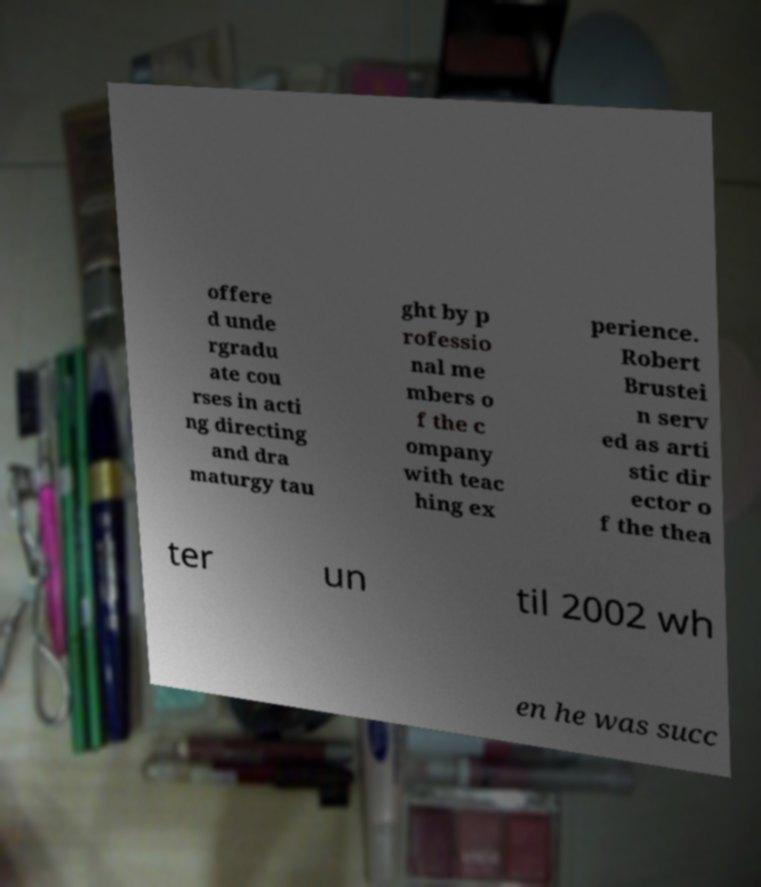Can you accurately transcribe the text from the provided image for me? offere d unde rgradu ate cou rses in acti ng directing and dra maturgy tau ght by p rofessio nal me mbers o f the c ompany with teac hing ex perience. Robert Brustei n serv ed as arti stic dir ector o f the thea ter un til 2002 wh en he was succ 